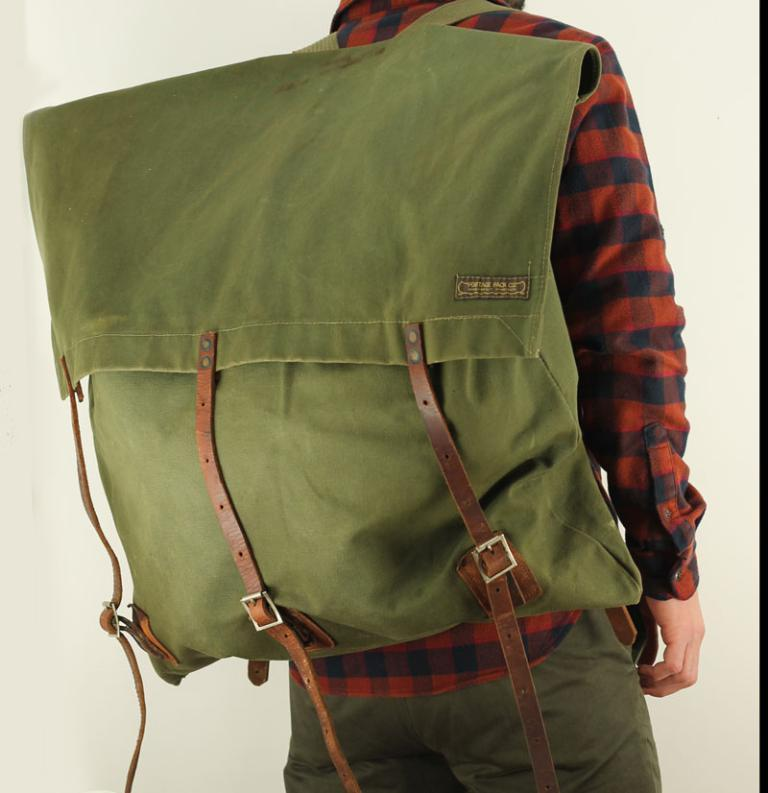Who is present in the image? There is a guy in the image. What is the guy wearing? The guy is wearing a green bag. Can you describe the green bag in more detail? The green bag has a brown color belt on it. How many belts are attached to the green bag? There are three belts to the bag. What type of animal is the bee interacting with the guy in the image? There is no bee present in the image, and therefore no interaction with the guy can be observed. Who is the partner of the guy in the image? The provided facts do not mention any partner or interaction with another person in the image. 